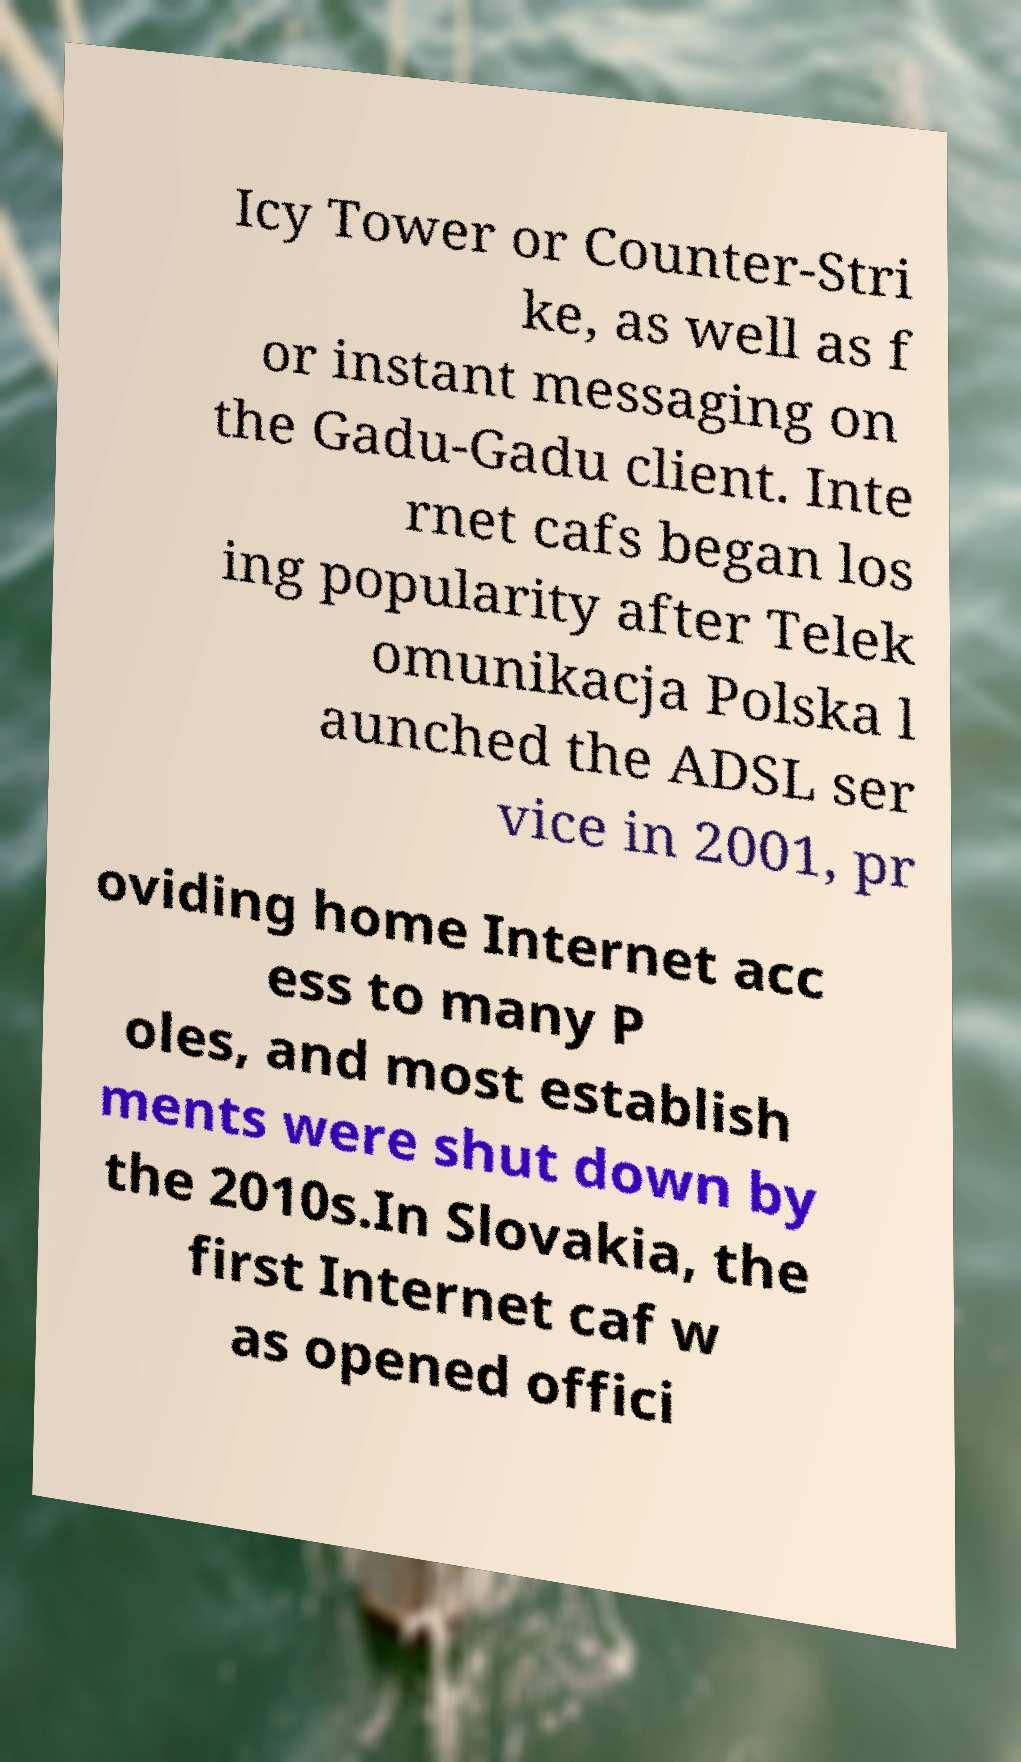Could you assist in decoding the text presented in this image and type it out clearly? Icy Tower or Counter-Stri ke, as well as f or instant messaging on the Gadu-Gadu client. Inte rnet cafs began los ing popularity after Telek omunikacja Polska l aunched the ADSL ser vice in 2001, pr oviding home Internet acc ess to many P oles, and most establish ments were shut down by the 2010s.In Slovakia, the first Internet caf w as opened offici 